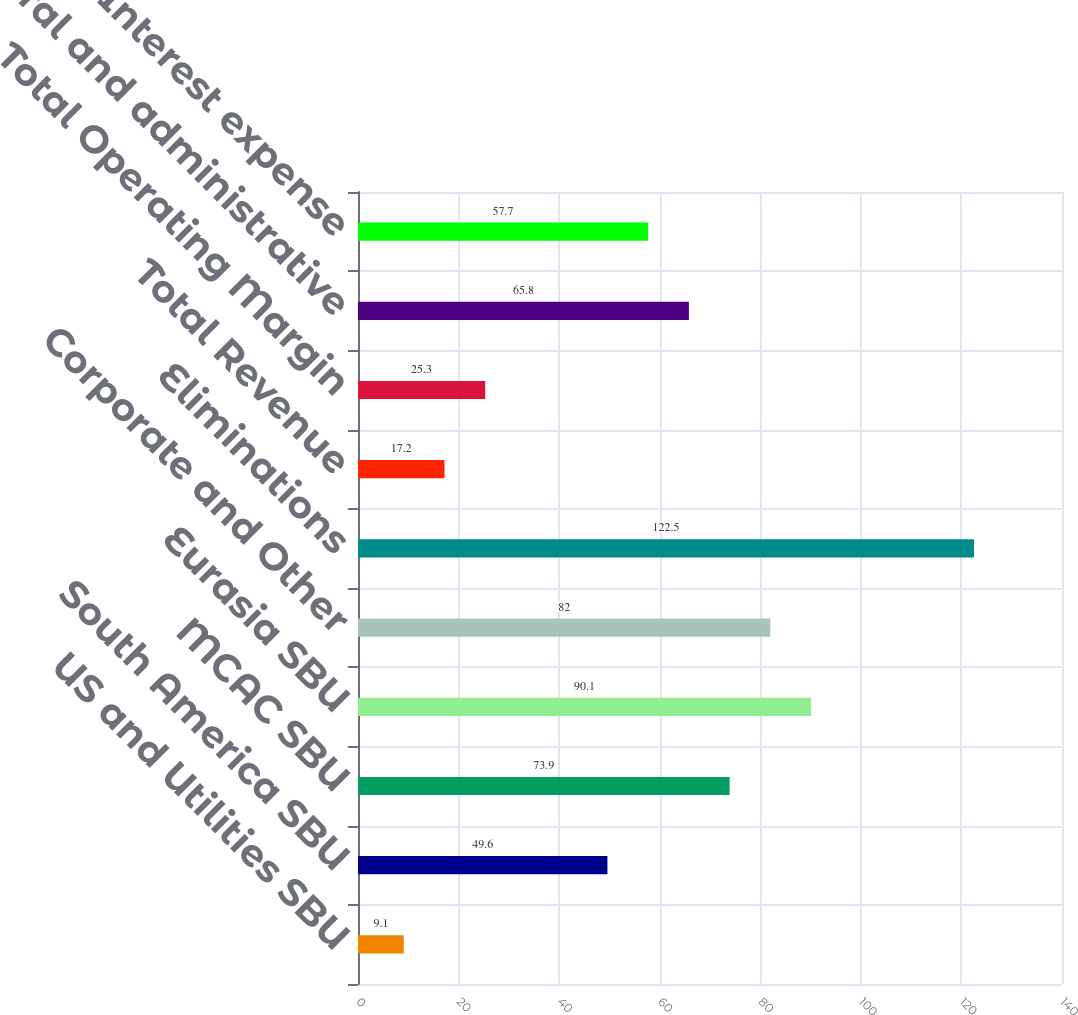Convert chart. <chart><loc_0><loc_0><loc_500><loc_500><bar_chart><fcel>US and Utilities SBU<fcel>South America SBU<fcel>MCAC SBU<fcel>Eurasia SBU<fcel>Corporate and Other<fcel>Eliminations<fcel>Total Revenue<fcel>Total Operating Margin<fcel>General and administrative<fcel>Interest expense<nl><fcel>9.1<fcel>49.6<fcel>73.9<fcel>90.1<fcel>82<fcel>122.5<fcel>17.2<fcel>25.3<fcel>65.8<fcel>57.7<nl></chart> 